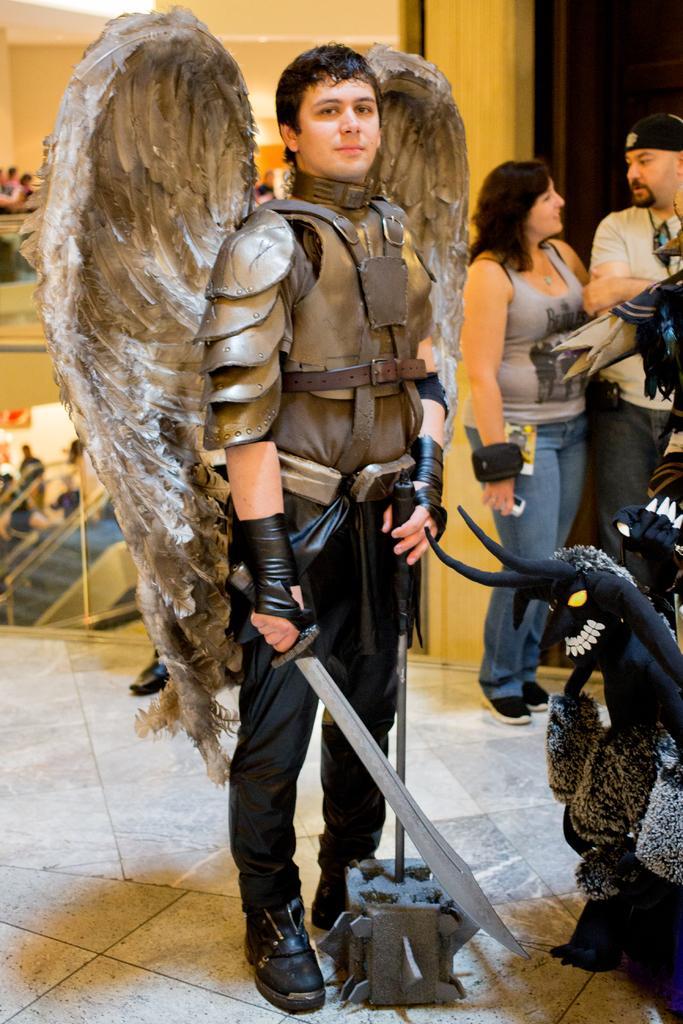Please provide a concise description of this image. In the center of the image a man is in cosplay and holding a machete and other object. On the right side of the image two persons are standing. In the background of the image we can see wall, stairs and some persons are there. At the bottom of the image floor is there. 